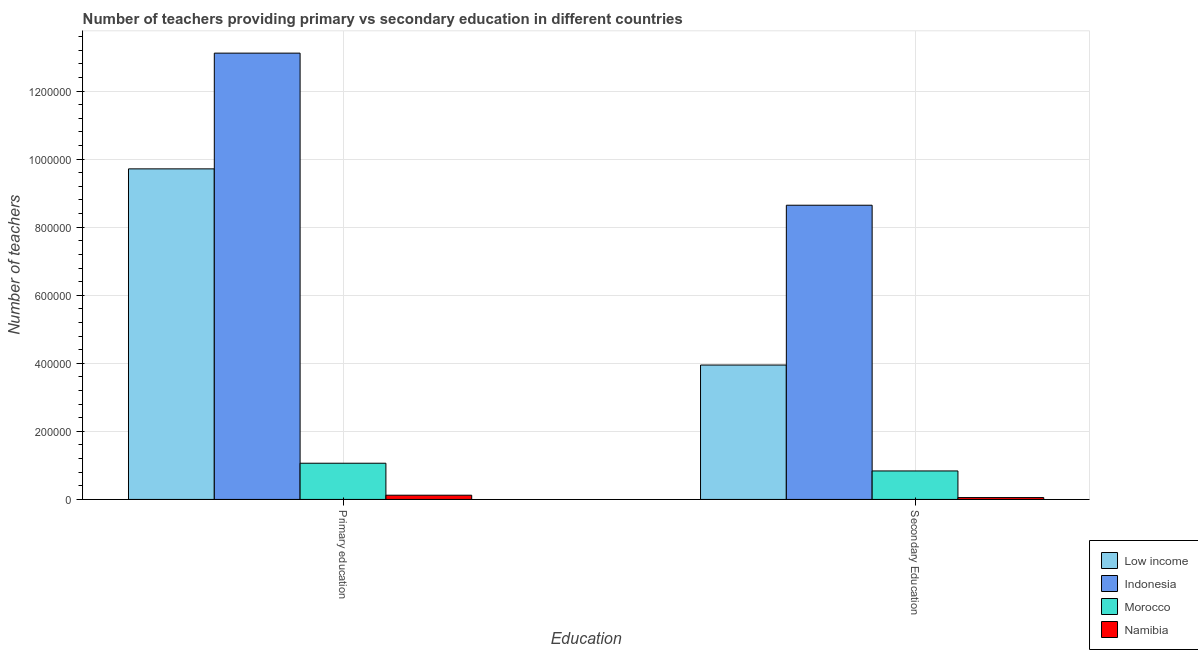How many different coloured bars are there?
Offer a very short reply. 4. How many bars are there on the 1st tick from the left?
Offer a very short reply. 4. How many bars are there on the 1st tick from the right?
Offer a terse response. 4. What is the label of the 2nd group of bars from the left?
Offer a terse response. Secondary Education. What is the number of secondary teachers in Indonesia?
Offer a very short reply. 8.65e+05. Across all countries, what is the maximum number of secondary teachers?
Offer a very short reply. 8.65e+05. Across all countries, what is the minimum number of secondary teachers?
Ensure brevity in your answer.  5460. In which country was the number of primary teachers maximum?
Your response must be concise. Indonesia. In which country was the number of secondary teachers minimum?
Your response must be concise. Namibia. What is the total number of primary teachers in the graph?
Make the answer very short. 2.40e+06. What is the difference between the number of secondary teachers in Morocco and that in Low income?
Your response must be concise. -3.11e+05. What is the difference between the number of secondary teachers in Namibia and the number of primary teachers in Indonesia?
Offer a terse response. -1.31e+06. What is the average number of secondary teachers per country?
Give a very brief answer. 3.37e+05. What is the difference between the number of primary teachers and number of secondary teachers in Morocco?
Your answer should be very brief. 2.27e+04. In how many countries, is the number of primary teachers greater than 560000 ?
Ensure brevity in your answer.  2. What is the ratio of the number of primary teachers in Low income to that in Namibia?
Offer a terse response. 78.46. What does the 1st bar from the right in Primary education represents?
Make the answer very short. Namibia. How many bars are there?
Your answer should be compact. 8. Are all the bars in the graph horizontal?
Ensure brevity in your answer.  No. What is the difference between two consecutive major ticks on the Y-axis?
Provide a succinct answer. 2.00e+05. Does the graph contain any zero values?
Make the answer very short. No. Does the graph contain grids?
Make the answer very short. Yes. What is the title of the graph?
Your response must be concise. Number of teachers providing primary vs secondary education in different countries. Does "Brazil" appear as one of the legend labels in the graph?
Keep it short and to the point. No. What is the label or title of the X-axis?
Offer a terse response. Education. What is the label or title of the Y-axis?
Your answer should be very brief. Number of teachers. What is the Number of teachers of Low income in Primary education?
Offer a very short reply. 9.71e+05. What is the Number of teachers in Indonesia in Primary education?
Your answer should be compact. 1.31e+06. What is the Number of teachers of Morocco in Primary education?
Provide a succinct answer. 1.06e+05. What is the Number of teachers in Namibia in Primary education?
Offer a very short reply. 1.24e+04. What is the Number of teachers in Low income in Secondary Education?
Your answer should be compact. 3.95e+05. What is the Number of teachers of Indonesia in Secondary Education?
Provide a succinct answer. 8.65e+05. What is the Number of teachers of Morocco in Secondary Education?
Offer a terse response. 8.37e+04. What is the Number of teachers in Namibia in Secondary Education?
Provide a succinct answer. 5460. Across all Education, what is the maximum Number of teachers of Low income?
Ensure brevity in your answer.  9.71e+05. Across all Education, what is the maximum Number of teachers in Indonesia?
Ensure brevity in your answer.  1.31e+06. Across all Education, what is the maximum Number of teachers of Morocco?
Your answer should be very brief. 1.06e+05. Across all Education, what is the maximum Number of teachers in Namibia?
Offer a terse response. 1.24e+04. Across all Education, what is the minimum Number of teachers in Low income?
Your answer should be compact. 3.95e+05. Across all Education, what is the minimum Number of teachers in Indonesia?
Make the answer very short. 8.65e+05. Across all Education, what is the minimum Number of teachers of Morocco?
Your response must be concise. 8.37e+04. Across all Education, what is the minimum Number of teachers of Namibia?
Your answer should be compact. 5460. What is the total Number of teachers of Low income in the graph?
Provide a short and direct response. 1.37e+06. What is the total Number of teachers in Indonesia in the graph?
Provide a short and direct response. 2.18e+06. What is the total Number of teachers in Morocco in the graph?
Provide a short and direct response. 1.90e+05. What is the total Number of teachers in Namibia in the graph?
Keep it short and to the point. 1.78e+04. What is the difference between the Number of teachers in Low income in Primary education and that in Secondary Education?
Keep it short and to the point. 5.76e+05. What is the difference between the Number of teachers of Indonesia in Primary education and that in Secondary Education?
Your answer should be very brief. 4.47e+05. What is the difference between the Number of teachers in Morocco in Primary education and that in Secondary Education?
Give a very brief answer. 2.27e+04. What is the difference between the Number of teachers of Namibia in Primary education and that in Secondary Education?
Make the answer very short. 6921. What is the difference between the Number of teachers of Low income in Primary education and the Number of teachers of Indonesia in Secondary Education?
Provide a short and direct response. 1.07e+05. What is the difference between the Number of teachers of Low income in Primary education and the Number of teachers of Morocco in Secondary Education?
Your answer should be compact. 8.88e+05. What is the difference between the Number of teachers of Low income in Primary education and the Number of teachers of Namibia in Secondary Education?
Provide a short and direct response. 9.66e+05. What is the difference between the Number of teachers in Indonesia in Primary education and the Number of teachers in Morocco in Secondary Education?
Make the answer very short. 1.23e+06. What is the difference between the Number of teachers of Indonesia in Primary education and the Number of teachers of Namibia in Secondary Education?
Your answer should be very brief. 1.31e+06. What is the difference between the Number of teachers in Morocco in Primary education and the Number of teachers in Namibia in Secondary Education?
Your response must be concise. 1.01e+05. What is the average Number of teachers in Low income per Education?
Offer a terse response. 6.83e+05. What is the average Number of teachers of Indonesia per Education?
Provide a short and direct response. 1.09e+06. What is the average Number of teachers in Morocco per Education?
Keep it short and to the point. 9.50e+04. What is the average Number of teachers in Namibia per Education?
Make the answer very short. 8920.5. What is the difference between the Number of teachers of Low income and Number of teachers of Indonesia in Primary education?
Keep it short and to the point. -3.40e+05. What is the difference between the Number of teachers in Low income and Number of teachers in Morocco in Primary education?
Offer a very short reply. 8.65e+05. What is the difference between the Number of teachers of Low income and Number of teachers of Namibia in Primary education?
Give a very brief answer. 9.59e+05. What is the difference between the Number of teachers in Indonesia and Number of teachers in Morocco in Primary education?
Your response must be concise. 1.21e+06. What is the difference between the Number of teachers of Indonesia and Number of teachers of Namibia in Primary education?
Your response must be concise. 1.30e+06. What is the difference between the Number of teachers in Morocco and Number of teachers in Namibia in Primary education?
Your answer should be very brief. 9.40e+04. What is the difference between the Number of teachers in Low income and Number of teachers in Indonesia in Secondary Education?
Offer a terse response. -4.70e+05. What is the difference between the Number of teachers of Low income and Number of teachers of Morocco in Secondary Education?
Offer a very short reply. 3.11e+05. What is the difference between the Number of teachers in Low income and Number of teachers in Namibia in Secondary Education?
Provide a succinct answer. 3.89e+05. What is the difference between the Number of teachers of Indonesia and Number of teachers of Morocco in Secondary Education?
Keep it short and to the point. 7.81e+05. What is the difference between the Number of teachers of Indonesia and Number of teachers of Namibia in Secondary Education?
Your answer should be compact. 8.59e+05. What is the difference between the Number of teachers of Morocco and Number of teachers of Namibia in Secondary Education?
Your response must be concise. 7.82e+04. What is the ratio of the Number of teachers of Low income in Primary education to that in Secondary Education?
Provide a short and direct response. 2.46. What is the ratio of the Number of teachers in Indonesia in Primary education to that in Secondary Education?
Give a very brief answer. 1.52. What is the ratio of the Number of teachers in Morocco in Primary education to that in Secondary Education?
Offer a very short reply. 1.27. What is the ratio of the Number of teachers in Namibia in Primary education to that in Secondary Education?
Your response must be concise. 2.27. What is the difference between the highest and the second highest Number of teachers of Low income?
Offer a very short reply. 5.76e+05. What is the difference between the highest and the second highest Number of teachers of Indonesia?
Offer a very short reply. 4.47e+05. What is the difference between the highest and the second highest Number of teachers in Morocco?
Make the answer very short. 2.27e+04. What is the difference between the highest and the second highest Number of teachers of Namibia?
Offer a very short reply. 6921. What is the difference between the highest and the lowest Number of teachers in Low income?
Ensure brevity in your answer.  5.76e+05. What is the difference between the highest and the lowest Number of teachers in Indonesia?
Make the answer very short. 4.47e+05. What is the difference between the highest and the lowest Number of teachers in Morocco?
Your answer should be very brief. 2.27e+04. What is the difference between the highest and the lowest Number of teachers in Namibia?
Make the answer very short. 6921. 